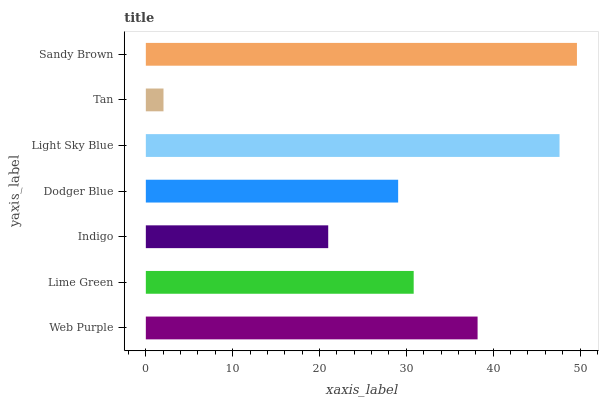Is Tan the minimum?
Answer yes or no. Yes. Is Sandy Brown the maximum?
Answer yes or no. Yes. Is Lime Green the minimum?
Answer yes or no. No. Is Lime Green the maximum?
Answer yes or no. No. Is Web Purple greater than Lime Green?
Answer yes or no. Yes. Is Lime Green less than Web Purple?
Answer yes or no. Yes. Is Lime Green greater than Web Purple?
Answer yes or no. No. Is Web Purple less than Lime Green?
Answer yes or no. No. Is Lime Green the high median?
Answer yes or no. Yes. Is Lime Green the low median?
Answer yes or no. Yes. Is Sandy Brown the high median?
Answer yes or no. No. Is Light Sky Blue the low median?
Answer yes or no. No. 